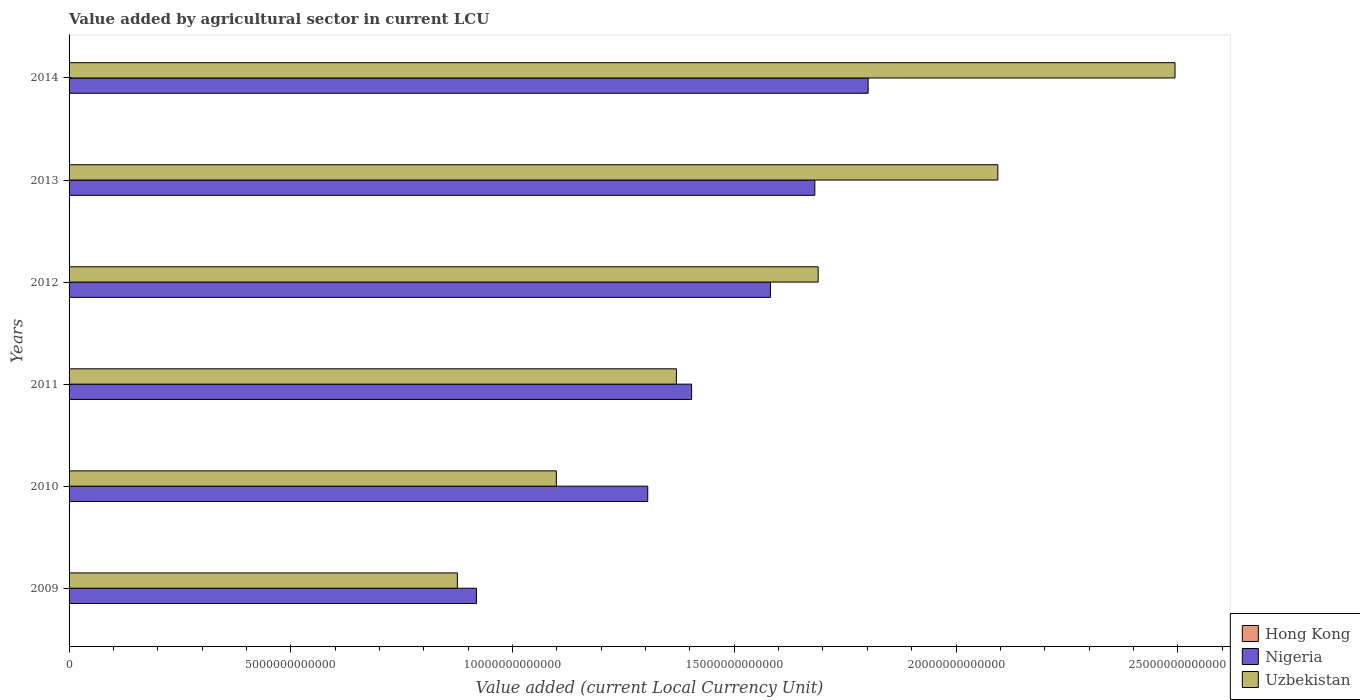How many groups of bars are there?
Keep it short and to the point. 6. Are the number of bars on each tick of the Y-axis equal?
Ensure brevity in your answer.  Yes. How many bars are there on the 6th tick from the bottom?
Ensure brevity in your answer.  3. What is the label of the 5th group of bars from the top?
Your answer should be compact. 2010. In how many cases, is the number of bars for a given year not equal to the number of legend labels?
Provide a succinct answer. 0. What is the value added by agricultural sector in Nigeria in 2013?
Offer a terse response. 1.68e+13. Across all years, what is the maximum value added by agricultural sector in Uzbekistan?
Give a very brief answer. 2.49e+13. Across all years, what is the minimum value added by agricultural sector in Uzbekistan?
Your answer should be compact. 8.76e+12. In which year was the value added by agricultural sector in Nigeria maximum?
Offer a very short reply. 2014. In which year was the value added by agricultural sector in Nigeria minimum?
Your answer should be compact. 2009. What is the total value added by agricultural sector in Uzbekistan in the graph?
Your answer should be very brief. 9.62e+13. What is the difference between the value added by agricultural sector in Hong Kong in 2011 and that in 2014?
Give a very brief answer. -5.52e+08. What is the difference between the value added by agricultural sector in Nigeria in 2009 and the value added by agricultural sector in Uzbekistan in 2012?
Your response must be concise. -7.71e+12. What is the average value added by agricultural sector in Hong Kong per year?
Give a very brief answer. 1.14e+09. In the year 2010, what is the difference between the value added by agricultural sector in Hong Kong and value added by agricultural sector in Nigeria?
Ensure brevity in your answer.  -1.30e+13. In how many years, is the value added by agricultural sector in Uzbekistan greater than 4000000000000 LCU?
Your answer should be very brief. 6. What is the ratio of the value added by agricultural sector in Hong Kong in 2010 to that in 2013?
Offer a terse response. 0.77. What is the difference between the highest and the second highest value added by agricultural sector in Nigeria?
Offer a very short reply. 1.20e+12. What is the difference between the highest and the lowest value added by agricultural sector in Nigeria?
Offer a very short reply. 8.83e+12. In how many years, is the value added by agricultural sector in Hong Kong greater than the average value added by agricultural sector in Hong Kong taken over all years?
Keep it short and to the point. 2. Is the sum of the value added by agricultural sector in Uzbekistan in 2009 and 2012 greater than the maximum value added by agricultural sector in Hong Kong across all years?
Make the answer very short. Yes. What does the 2nd bar from the top in 2014 represents?
Your answer should be compact. Nigeria. What does the 1st bar from the bottom in 2009 represents?
Keep it short and to the point. Hong Kong. Is it the case that in every year, the sum of the value added by agricultural sector in Hong Kong and value added by agricultural sector in Uzbekistan is greater than the value added by agricultural sector in Nigeria?
Keep it short and to the point. No. How many bars are there?
Provide a short and direct response. 18. How many years are there in the graph?
Offer a very short reply. 6. What is the difference between two consecutive major ticks on the X-axis?
Your response must be concise. 5.00e+12. Are the values on the major ticks of X-axis written in scientific E-notation?
Your answer should be compact. No. Does the graph contain any zero values?
Make the answer very short. No. Does the graph contain grids?
Give a very brief answer. No. How many legend labels are there?
Make the answer very short. 3. How are the legend labels stacked?
Ensure brevity in your answer.  Vertical. What is the title of the graph?
Provide a succinct answer. Value added by agricultural sector in current LCU. Does "Belgium" appear as one of the legend labels in the graph?
Make the answer very short. No. What is the label or title of the X-axis?
Provide a short and direct response. Value added (current Local Currency Unit). What is the Value added (current Local Currency Unit) in Hong Kong in 2009?
Provide a short and direct response. 1.09e+09. What is the Value added (current Local Currency Unit) of Nigeria in 2009?
Offer a very short reply. 9.19e+12. What is the Value added (current Local Currency Unit) of Uzbekistan in 2009?
Your answer should be compact. 8.76e+12. What is the Value added (current Local Currency Unit) in Hong Kong in 2010?
Make the answer very short. 9.48e+08. What is the Value added (current Local Currency Unit) of Nigeria in 2010?
Give a very brief answer. 1.30e+13. What is the Value added (current Local Currency Unit) of Uzbekistan in 2010?
Your answer should be very brief. 1.10e+13. What is the Value added (current Local Currency Unit) in Hong Kong in 2011?
Give a very brief answer. 9.44e+08. What is the Value added (current Local Currency Unit) of Nigeria in 2011?
Offer a very short reply. 1.40e+13. What is the Value added (current Local Currency Unit) of Uzbekistan in 2011?
Ensure brevity in your answer.  1.37e+13. What is the Value added (current Local Currency Unit) in Hong Kong in 2012?
Your response must be concise. 1.11e+09. What is the Value added (current Local Currency Unit) of Nigeria in 2012?
Ensure brevity in your answer.  1.58e+13. What is the Value added (current Local Currency Unit) in Uzbekistan in 2012?
Your response must be concise. 1.69e+13. What is the Value added (current Local Currency Unit) of Hong Kong in 2013?
Offer a terse response. 1.22e+09. What is the Value added (current Local Currency Unit) in Nigeria in 2013?
Offer a very short reply. 1.68e+13. What is the Value added (current Local Currency Unit) in Uzbekistan in 2013?
Provide a succinct answer. 2.09e+13. What is the Value added (current Local Currency Unit) in Hong Kong in 2014?
Provide a short and direct response. 1.50e+09. What is the Value added (current Local Currency Unit) in Nigeria in 2014?
Offer a very short reply. 1.80e+13. What is the Value added (current Local Currency Unit) of Uzbekistan in 2014?
Offer a terse response. 2.49e+13. Across all years, what is the maximum Value added (current Local Currency Unit) of Hong Kong?
Ensure brevity in your answer.  1.50e+09. Across all years, what is the maximum Value added (current Local Currency Unit) of Nigeria?
Offer a terse response. 1.80e+13. Across all years, what is the maximum Value added (current Local Currency Unit) in Uzbekistan?
Provide a succinct answer. 2.49e+13. Across all years, what is the minimum Value added (current Local Currency Unit) of Hong Kong?
Keep it short and to the point. 9.44e+08. Across all years, what is the minimum Value added (current Local Currency Unit) of Nigeria?
Your response must be concise. 9.19e+12. Across all years, what is the minimum Value added (current Local Currency Unit) of Uzbekistan?
Ensure brevity in your answer.  8.76e+12. What is the total Value added (current Local Currency Unit) of Hong Kong in the graph?
Your answer should be compact. 6.82e+09. What is the total Value added (current Local Currency Unit) in Nigeria in the graph?
Ensure brevity in your answer.  8.69e+13. What is the total Value added (current Local Currency Unit) in Uzbekistan in the graph?
Your answer should be compact. 9.62e+13. What is the difference between the Value added (current Local Currency Unit) in Hong Kong in 2009 and that in 2010?
Keep it short and to the point. 1.42e+08. What is the difference between the Value added (current Local Currency Unit) in Nigeria in 2009 and that in 2010?
Offer a terse response. -3.86e+12. What is the difference between the Value added (current Local Currency Unit) in Uzbekistan in 2009 and that in 2010?
Give a very brief answer. -2.23e+12. What is the difference between the Value added (current Local Currency Unit) of Hong Kong in 2009 and that in 2011?
Make the answer very short. 1.46e+08. What is the difference between the Value added (current Local Currency Unit) of Nigeria in 2009 and that in 2011?
Offer a very short reply. -4.85e+12. What is the difference between the Value added (current Local Currency Unit) of Uzbekistan in 2009 and that in 2011?
Keep it short and to the point. -4.94e+12. What is the difference between the Value added (current Local Currency Unit) of Hong Kong in 2009 and that in 2012?
Make the answer very short. -2.40e+07. What is the difference between the Value added (current Local Currency Unit) in Nigeria in 2009 and that in 2012?
Offer a very short reply. -6.63e+12. What is the difference between the Value added (current Local Currency Unit) of Uzbekistan in 2009 and that in 2012?
Offer a terse response. -8.14e+12. What is the difference between the Value added (current Local Currency Unit) in Hong Kong in 2009 and that in 2013?
Offer a terse response. -1.35e+08. What is the difference between the Value added (current Local Currency Unit) in Nigeria in 2009 and that in 2013?
Make the answer very short. -7.63e+12. What is the difference between the Value added (current Local Currency Unit) of Uzbekistan in 2009 and that in 2013?
Make the answer very short. -1.22e+13. What is the difference between the Value added (current Local Currency Unit) of Hong Kong in 2009 and that in 2014?
Ensure brevity in your answer.  -4.06e+08. What is the difference between the Value added (current Local Currency Unit) of Nigeria in 2009 and that in 2014?
Give a very brief answer. -8.83e+12. What is the difference between the Value added (current Local Currency Unit) in Uzbekistan in 2009 and that in 2014?
Give a very brief answer. -1.62e+13. What is the difference between the Value added (current Local Currency Unit) of Hong Kong in 2010 and that in 2011?
Provide a succinct answer. 4.00e+06. What is the difference between the Value added (current Local Currency Unit) in Nigeria in 2010 and that in 2011?
Keep it short and to the point. -9.89e+11. What is the difference between the Value added (current Local Currency Unit) in Uzbekistan in 2010 and that in 2011?
Give a very brief answer. -2.71e+12. What is the difference between the Value added (current Local Currency Unit) of Hong Kong in 2010 and that in 2012?
Your answer should be compact. -1.66e+08. What is the difference between the Value added (current Local Currency Unit) in Nigeria in 2010 and that in 2012?
Offer a terse response. -2.77e+12. What is the difference between the Value added (current Local Currency Unit) in Uzbekistan in 2010 and that in 2012?
Offer a terse response. -5.90e+12. What is the difference between the Value added (current Local Currency Unit) of Hong Kong in 2010 and that in 2013?
Give a very brief answer. -2.77e+08. What is the difference between the Value added (current Local Currency Unit) of Nigeria in 2010 and that in 2013?
Offer a very short reply. -3.77e+12. What is the difference between the Value added (current Local Currency Unit) in Uzbekistan in 2010 and that in 2013?
Provide a short and direct response. -9.96e+12. What is the difference between the Value added (current Local Currency Unit) in Hong Kong in 2010 and that in 2014?
Give a very brief answer. -5.48e+08. What is the difference between the Value added (current Local Currency Unit) in Nigeria in 2010 and that in 2014?
Offer a very short reply. -4.97e+12. What is the difference between the Value added (current Local Currency Unit) of Uzbekistan in 2010 and that in 2014?
Offer a very short reply. -1.40e+13. What is the difference between the Value added (current Local Currency Unit) of Hong Kong in 2011 and that in 2012?
Make the answer very short. -1.70e+08. What is the difference between the Value added (current Local Currency Unit) in Nigeria in 2011 and that in 2012?
Make the answer very short. -1.78e+12. What is the difference between the Value added (current Local Currency Unit) of Uzbekistan in 2011 and that in 2012?
Offer a very short reply. -3.20e+12. What is the difference between the Value added (current Local Currency Unit) of Hong Kong in 2011 and that in 2013?
Your answer should be compact. -2.81e+08. What is the difference between the Value added (current Local Currency Unit) in Nigeria in 2011 and that in 2013?
Ensure brevity in your answer.  -2.78e+12. What is the difference between the Value added (current Local Currency Unit) of Uzbekistan in 2011 and that in 2013?
Provide a short and direct response. -7.25e+12. What is the difference between the Value added (current Local Currency Unit) in Hong Kong in 2011 and that in 2014?
Keep it short and to the point. -5.52e+08. What is the difference between the Value added (current Local Currency Unit) of Nigeria in 2011 and that in 2014?
Provide a succinct answer. -3.98e+12. What is the difference between the Value added (current Local Currency Unit) in Uzbekistan in 2011 and that in 2014?
Ensure brevity in your answer.  -1.12e+13. What is the difference between the Value added (current Local Currency Unit) of Hong Kong in 2012 and that in 2013?
Give a very brief answer. -1.11e+08. What is the difference between the Value added (current Local Currency Unit) in Nigeria in 2012 and that in 2013?
Your answer should be compact. -1.00e+12. What is the difference between the Value added (current Local Currency Unit) of Uzbekistan in 2012 and that in 2013?
Give a very brief answer. -4.05e+12. What is the difference between the Value added (current Local Currency Unit) of Hong Kong in 2012 and that in 2014?
Provide a short and direct response. -3.82e+08. What is the difference between the Value added (current Local Currency Unit) of Nigeria in 2012 and that in 2014?
Offer a very short reply. -2.20e+12. What is the difference between the Value added (current Local Currency Unit) in Uzbekistan in 2012 and that in 2014?
Your response must be concise. -8.05e+12. What is the difference between the Value added (current Local Currency Unit) in Hong Kong in 2013 and that in 2014?
Keep it short and to the point. -2.71e+08. What is the difference between the Value added (current Local Currency Unit) of Nigeria in 2013 and that in 2014?
Give a very brief answer. -1.20e+12. What is the difference between the Value added (current Local Currency Unit) of Uzbekistan in 2013 and that in 2014?
Your response must be concise. -3.99e+12. What is the difference between the Value added (current Local Currency Unit) in Hong Kong in 2009 and the Value added (current Local Currency Unit) in Nigeria in 2010?
Provide a succinct answer. -1.30e+13. What is the difference between the Value added (current Local Currency Unit) in Hong Kong in 2009 and the Value added (current Local Currency Unit) in Uzbekistan in 2010?
Your response must be concise. -1.10e+13. What is the difference between the Value added (current Local Currency Unit) of Nigeria in 2009 and the Value added (current Local Currency Unit) of Uzbekistan in 2010?
Ensure brevity in your answer.  -1.80e+12. What is the difference between the Value added (current Local Currency Unit) in Hong Kong in 2009 and the Value added (current Local Currency Unit) in Nigeria in 2011?
Ensure brevity in your answer.  -1.40e+13. What is the difference between the Value added (current Local Currency Unit) of Hong Kong in 2009 and the Value added (current Local Currency Unit) of Uzbekistan in 2011?
Your answer should be very brief. -1.37e+13. What is the difference between the Value added (current Local Currency Unit) in Nigeria in 2009 and the Value added (current Local Currency Unit) in Uzbekistan in 2011?
Your response must be concise. -4.51e+12. What is the difference between the Value added (current Local Currency Unit) in Hong Kong in 2009 and the Value added (current Local Currency Unit) in Nigeria in 2012?
Your response must be concise. -1.58e+13. What is the difference between the Value added (current Local Currency Unit) in Hong Kong in 2009 and the Value added (current Local Currency Unit) in Uzbekistan in 2012?
Offer a very short reply. -1.69e+13. What is the difference between the Value added (current Local Currency Unit) in Nigeria in 2009 and the Value added (current Local Currency Unit) in Uzbekistan in 2012?
Your answer should be very brief. -7.71e+12. What is the difference between the Value added (current Local Currency Unit) in Hong Kong in 2009 and the Value added (current Local Currency Unit) in Nigeria in 2013?
Make the answer very short. -1.68e+13. What is the difference between the Value added (current Local Currency Unit) of Hong Kong in 2009 and the Value added (current Local Currency Unit) of Uzbekistan in 2013?
Provide a succinct answer. -2.09e+13. What is the difference between the Value added (current Local Currency Unit) of Nigeria in 2009 and the Value added (current Local Currency Unit) of Uzbekistan in 2013?
Your answer should be compact. -1.18e+13. What is the difference between the Value added (current Local Currency Unit) of Hong Kong in 2009 and the Value added (current Local Currency Unit) of Nigeria in 2014?
Provide a short and direct response. -1.80e+13. What is the difference between the Value added (current Local Currency Unit) in Hong Kong in 2009 and the Value added (current Local Currency Unit) in Uzbekistan in 2014?
Provide a short and direct response. -2.49e+13. What is the difference between the Value added (current Local Currency Unit) in Nigeria in 2009 and the Value added (current Local Currency Unit) in Uzbekistan in 2014?
Keep it short and to the point. -1.58e+13. What is the difference between the Value added (current Local Currency Unit) in Hong Kong in 2010 and the Value added (current Local Currency Unit) in Nigeria in 2011?
Offer a terse response. -1.40e+13. What is the difference between the Value added (current Local Currency Unit) of Hong Kong in 2010 and the Value added (current Local Currency Unit) of Uzbekistan in 2011?
Offer a very short reply. -1.37e+13. What is the difference between the Value added (current Local Currency Unit) in Nigeria in 2010 and the Value added (current Local Currency Unit) in Uzbekistan in 2011?
Ensure brevity in your answer.  -6.46e+11. What is the difference between the Value added (current Local Currency Unit) of Hong Kong in 2010 and the Value added (current Local Currency Unit) of Nigeria in 2012?
Make the answer very short. -1.58e+13. What is the difference between the Value added (current Local Currency Unit) in Hong Kong in 2010 and the Value added (current Local Currency Unit) in Uzbekistan in 2012?
Give a very brief answer. -1.69e+13. What is the difference between the Value added (current Local Currency Unit) in Nigeria in 2010 and the Value added (current Local Currency Unit) in Uzbekistan in 2012?
Ensure brevity in your answer.  -3.84e+12. What is the difference between the Value added (current Local Currency Unit) in Hong Kong in 2010 and the Value added (current Local Currency Unit) in Nigeria in 2013?
Ensure brevity in your answer.  -1.68e+13. What is the difference between the Value added (current Local Currency Unit) in Hong Kong in 2010 and the Value added (current Local Currency Unit) in Uzbekistan in 2013?
Offer a very short reply. -2.09e+13. What is the difference between the Value added (current Local Currency Unit) of Nigeria in 2010 and the Value added (current Local Currency Unit) of Uzbekistan in 2013?
Offer a very short reply. -7.89e+12. What is the difference between the Value added (current Local Currency Unit) in Hong Kong in 2010 and the Value added (current Local Currency Unit) in Nigeria in 2014?
Give a very brief answer. -1.80e+13. What is the difference between the Value added (current Local Currency Unit) of Hong Kong in 2010 and the Value added (current Local Currency Unit) of Uzbekistan in 2014?
Your response must be concise. -2.49e+13. What is the difference between the Value added (current Local Currency Unit) in Nigeria in 2010 and the Value added (current Local Currency Unit) in Uzbekistan in 2014?
Your response must be concise. -1.19e+13. What is the difference between the Value added (current Local Currency Unit) of Hong Kong in 2011 and the Value added (current Local Currency Unit) of Nigeria in 2012?
Keep it short and to the point. -1.58e+13. What is the difference between the Value added (current Local Currency Unit) of Hong Kong in 2011 and the Value added (current Local Currency Unit) of Uzbekistan in 2012?
Make the answer very short. -1.69e+13. What is the difference between the Value added (current Local Currency Unit) in Nigeria in 2011 and the Value added (current Local Currency Unit) in Uzbekistan in 2012?
Provide a succinct answer. -2.85e+12. What is the difference between the Value added (current Local Currency Unit) in Hong Kong in 2011 and the Value added (current Local Currency Unit) in Nigeria in 2013?
Your answer should be very brief. -1.68e+13. What is the difference between the Value added (current Local Currency Unit) in Hong Kong in 2011 and the Value added (current Local Currency Unit) in Uzbekistan in 2013?
Your response must be concise. -2.09e+13. What is the difference between the Value added (current Local Currency Unit) of Nigeria in 2011 and the Value added (current Local Currency Unit) of Uzbekistan in 2013?
Ensure brevity in your answer.  -6.91e+12. What is the difference between the Value added (current Local Currency Unit) in Hong Kong in 2011 and the Value added (current Local Currency Unit) in Nigeria in 2014?
Provide a succinct answer. -1.80e+13. What is the difference between the Value added (current Local Currency Unit) in Hong Kong in 2011 and the Value added (current Local Currency Unit) in Uzbekistan in 2014?
Your response must be concise. -2.49e+13. What is the difference between the Value added (current Local Currency Unit) of Nigeria in 2011 and the Value added (current Local Currency Unit) of Uzbekistan in 2014?
Provide a succinct answer. -1.09e+13. What is the difference between the Value added (current Local Currency Unit) of Hong Kong in 2012 and the Value added (current Local Currency Unit) of Nigeria in 2013?
Your answer should be very brief. -1.68e+13. What is the difference between the Value added (current Local Currency Unit) in Hong Kong in 2012 and the Value added (current Local Currency Unit) in Uzbekistan in 2013?
Provide a short and direct response. -2.09e+13. What is the difference between the Value added (current Local Currency Unit) of Nigeria in 2012 and the Value added (current Local Currency Unit) of Uzbekistan in 2013?
Provide a succinct answer. -5.13e+12. What is the difference between the Value added (current Local Currency Unit) in Hong Kong in 2012 and the Value added (current Local Currency Unit) in Nigeria in 2014?
Your response must be concise. -1.80e+13. What is the difference between the Value added (current Local Currency Unit) of Hong Kong in 2012 and the Value added (current Local Currency Unit) of Uzbekistan in 2014?
Ensure brevity in your answer.  -2.49e+13. What is the difference between the Value added (current Local Currency Unit) in Nigeria in 2012 and the Value added (current Local Currency Unit) in Uzbekistan in 2014?
Give a very brief answer. -9.12e+12. What is the difference between the Value added (current Local Currency Unit) of Hong Kong in 2013 and the Value added (current Local Currency Unit) of Nigeria in 2014?
Offer a very short reply. -1.80e+13. What is the difference between the Value added (current Local Currency Unit) of Hong Kong in 2013 and the Value added (current Local Currency Unit) of Uzbekistan in 2014?
Your answer should be compact. -2.49e+13. What is the difference between the Value added (current Local Currency Unit) of Nigeria in 2013 and the Value added (current Local Currency Unit) of Uzbekistan in 2014?
Your response must be concise. -8.12e+12. What is the average Value added (current Local Currency Unit) in Hong Kong per year?
Make the answer very short. 1.14e+09. What is the average Value added (current Local Currency Unit) in Nigeria per year?
Provide a succinct answer. 1.45e+13. What is the average Value added (current Local Currency Unit) of Uzbekistan per year?
Give a very brief answer. 1.60e+13. In the year 2009, what is the difference between the Value added (current Local Currency Unit) in Hong Kong and Value added (current Local Currency Unit) in Nigeria?
Your response must be concise. -9.19e+12. In the year 2009, what is the difference between the Value added (current Local Currency Unit) in Hong Kong and Value added (current Local Currency Unit) in Uzbekistan?
Your answer should be compact. -8.75e+12. In the year 2009, what is the difference between the Value added (current Local Currency Unit) in Nigeria and Value added (current Local Currency Unit) in Uzbekistan?
Provide a succinct answer. 4.30e+11. In the year 2010, what is the difference between the Value added (current Local Currency Unit) of Hong Kong and Value added (current Local Currency Unit) of Nigeria?
Make the answer very short. -1.30e+13. In the year 2010, what is the difference between the Value added (current Local Currency Unit) in Hong Kong and Value added (current Local Currency Unit) in Uzbekistan?
Offer a very short reply. -1.10e+13. In the year 2010, what is the difference between the Value added (current Local Currency Unit) of Nigeria and Value added (current Local Currency Unit) of Uzbekistan?
Your response must be concise. 2.06e+12. In the year 2011, what is the difference between the Value added (current Local Currency Unit) in Hong Kong and Value added (current Local Currency Unit) in Nigeria?
Give a very brief answer. -1.40e+13. In the year 2011, what is the difference between the Value added (current Local Currency Unit) in Hong Kong and Value added (current Local Currency Unit) in Uzbekistan?
Provide a succinct answer. -1.37e+13. In the year 2011, what is the difference between the Value added (current Local Currency Unit) in Nigeria and Value added (current Local Currency Unit) in Uzbekistan?
Provide a short and direct response. 3.43e+11. In the year 2012, what is the difference between the Value added (current Local Currency Unit) of Hong Kong and Value added (current Local Currency Unit) of Nigeria?
Offer a very short reply. -1.58e+13. In the year 2012, what is the difference between the Value added (current Local Currency Unit) of Hong Kong and Value added (current Local Currency Unit) of Uzbekistan?
Ensure brevity in your answer.  -1.69e+13. In the year 2012, what is the difference between the Value added (current Local Currency Unit) of Nigeria and Value added (current Local Currency Unit) of Uzbekistan?
Provide a short and direct response. -1.08e+12. In the year 2013, what is the difference between the Value added (current Local Currency Unit) in Hong Kong and Value added (current Local Currency Unit) in Nigeria?
Make the answer very short. -1.68e+13. In the year 2013, what is the difference between the Value added (current Local Currency Unit) in Hong Kong and Value added (current Local Currency Unit) in Uzbekistan?
Provide a short and direct response. -2.09e+13. In the year 2013, what is the difference between the Value added (current Local Currency Unit) in Nigeria and Value added (current Local Currency Unit) in Uzbekistan?
Your response must be concise. -4.13e+12. In the year 2014, what is the difference between the Value added (current Local Currency Unit) in Hong Kong and Value added (current Local Currency Unit) in Nigeria?
Offer a very short reply. -1.80e+13. In the year 2014, what is the difference between the Value added (current Local Currency Unit) in Hong Kong and Value added (current Local Currency Unit) in Uzbekistan?
Provide a succinct answer. -2.49e+13. In the year 2014, what is the difference between the Value added (current Local Currency Unit) in Nigeria and Value added (current Local Currency Unit) in Uzbekistan?
Offer a very short reply. -6.92e+12. What is the ratio of the Value added (current Local Currency Unit) of Hong Kong in 2009 to that in 2010?
Your answer should be compact. 1.15. What is the ratio of the Value added (current Local Currency Unit) of Nigeria in 2009 to that in 2010?
Give a very brief answer. 0.7. What is the ratio of the Value added (current Local Currency Unit) in Uzbekistan in 2009 to that in 2010?
Provide a succinct answer. 0.8. What is the ratio of the Value added (current Local Currency Unit) in Hong Kong in 2009 to that in 2011?
Keep it short and to the point. 1.15. What is the ratio of the Value added (current Local Currency Unit) in Nigeria in 2009 to that in 2011?
Your answer should be very brief. 0.65. What is the ratio of the Value added (current Local Currency Unit) of Uzbekistan in 2009 to that in 2011?
Your answer should be very brief. 0.64. What is the ratio of the Value added (current Local Currency Unit) of Hong Kong in 2009 to that in 2012?
Provide a succinct answer. 0.98. What is the ratio of the Value added (current Local Currency Unit) in Nigeria in 2009 to that in 2012?
Offer a terse response. 0.58. What is the ratio of the Value added (current Local Currency Unit) in Uzbekistan in 2009 to that in 2012?
Your answer should be very brief. 0.52. What is the ratio of the Value added (current Local Currency Unit) in Hong Kong in 2009 to that in 2013?
Offer a very short reply. 0.89. What is the ratio of the Value added (current Local Currency Unit) of Nigeria in 2009 to that in 2013?
Provide a succinct answer. 0.55. What is the ratio of the Value added (current Local Currency Unit) of Uzbekistan in 2009 to that in 2013?
Offer a very short reply. 0.42. What is the ratio of the Value added (current Local Currency Unit) of Hong Kong in 2009 to that in 2014?
Give a very brief answer. 0.73. What is the ratio of the Value added (current Local Currency Unit) of Nigeria in 2009 to that in 2014?
Your answer should be very brief. 0.51. What is the ratio of the Value added (current Local Currency Unit) in Uzbekistan in 2009 to that in 2014?
Your response must be concise. 0.35. What is the ratio of the Value added (current Local Currency Unit) of Hong Kong in 2010 to that in 2011?
Give a very brief answer. 1. What is the ratio of the Value added (current Local Currency Unit) in Nigeria in 2010 to that in 2011?
Give a very brief answer. 0.93. What is the ratio of the Value added (current Local Currency Unit) in Uzbekistan in 2010 to that in 2011?
Offer a terse response. 0.8. What is the ratio of the Value added (current Local Currency Unit) of Hong Kong in 2010 to that in 2012?
Your answer should be compact. 0.85. What is the ratio of the Value added (current Local Currency Unit) in Nigeria in 2010 to that in 2012?
Give a very brief answer. 0.82. What is the ratio of the Value added (current Local Currency Unit) of Uzbekistan in 2010 to that in 2012?
Make the answer very short. 0.65. What is the ratio of the Value added (current Local Currency Unit) in Hong Kong in 2010 to that in 2013?
Your answer should be very brief. 0.77. What is the ratio of the Value added (current Local Currency Unit) in Nigeria in 2010 to that in 2013?
Your answer should be compact. 0.78. What is the ratio of the Value added (current Local Currency Unit) of Uzbekistan in 2010 to that in 2013?
Provide a short and direct response. 0.52. What is the ratio of the Value added (current Local Currency Unit) in Hong Kong in 2010 to that in 2014?
Provide a short and direct response. 0.63. What is the ratio of the Value added (current Local Currency Unit) of Nigeria in 2010 to that in 2014?
Offer a terse response. 0.72. What is the ratio of the Value added (current Local Currency Unit) in Uzbekistan in 2010 to that in 2014?
Provide a succinct answer. 0.44. What is the ratio of the Value added (current Local Currency Unit) of Hong Kong in 2011 to that in 2012?
Your response must be concise. 0.85. What is the ratio of the Value added (current Local Currency Unit) in Nigeria in 2011 to that in 2012?
Offer a very short reply. 0.89. What is the ratio of the Value added (current Local Currency Unit) in Uzbekistan in 2011 to that in 2012?
Your answer should be compact. 0.81. What is the ratio of the Value added (current Local Currency Unit) of Hong Kong in 2011 to that in 2013?
Keep it short and to the point. 0.77. What is the ratio of the Value added (current Local Currency Unit) of Nigeria in 2011 to that in 2013?
Your response must be concise. 0.83. What is the ratio of the Value added (current Local Currency Unit) in Uzbekistan in 2011 to that in 2013?
Provide a succinct answer. 0.65. What is the ratio of the Value added (current Local Currency Unit) in Hong Kong in 2011 to that in 2014?
Keep it short and to the point. 0.63. What is the ratio of the Value added (current Local Currency Unit) of Nigeria in 2011 to that in 2014?
Your answer should be very brief. 0.78. What is the ratio of the Value added (current Local Currency Unit) of Uzbekistan in 2011 to that in 2014?
Offer a very short reply. 0.55. What is the ratio of the Value added (current Local Currency Unit) of Hong Kong in 2012 to that in 2013?
Ensure brevity in your answer.  0.91. What is the ratio of the Value added (current Local Currency Unit) in Nigeria in 2012 to that in 2013?
Ensure brevity in your answer.  0.94. What is the ratio of the Value added (current Local Currency Unit) in Uzbekistan in 2012 to that in 2013?
Your answer should be very brief. 0.81. What is the ratio of the Value added (current Local Currency Unit) in Hong Kong in 2012 to that in 2014?
Give a very brief answer. 0.74. What is the ratio of the Value added (current Local Currency Unit) of Nigeria in 2012 to that in 2014?
Provide a short and direct response. 0.88. What is the ratio of the Value added (current Local Currency Unit) in Uzbekistan in 2012 to that in 2014?
Your answer should be compact. 0.68. What is the ratio of the Value added (current Local Currency Unit) in Hong Kong in 2013 to that in 2014?
Provide a short and direct response. 0.82. What is the ratio of the Value added (current Local Currency Unit) in Uzbekistan in 2013 to that in 2014?
Provide a short and direct response. 0.84. What is the difference between the highest and the second highest Value added (current Local Currency Unit) in Hong Kong?
Keep it short and to the point. 2.71e+08. What is the difference between the highest and the second highest Value added (current Local Currency Unit) in Nigeria?
Your response must be concise. 1.20e+12. What is the difference between the highest and the second highest Value added (current Local Currency Unit) of Uzbekistan?
Keep it short and to the point. 3.99e+12. What is the difference between the highest and the lowest Value added (current Local Currency Unit) in Hong Kong?
Provide a succinct answer. 5.52e+08. What is the difference between the highest and the lowest Value added (current Local Currency Unit) of Nigeria?
Ensure brevity in your answer.  8.83e+12. What is the difference between the highest and the lowest Value added (current Local Currency Unit) of Uzbekistan?
Offer a very short reply. 1.62e+13. 